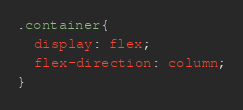Convert code to text. <code><loc_0><loc_0><loc_500><loc_500><_CSS_>.container{
  display: flex;
  flex-direction: column;
}
</code> 